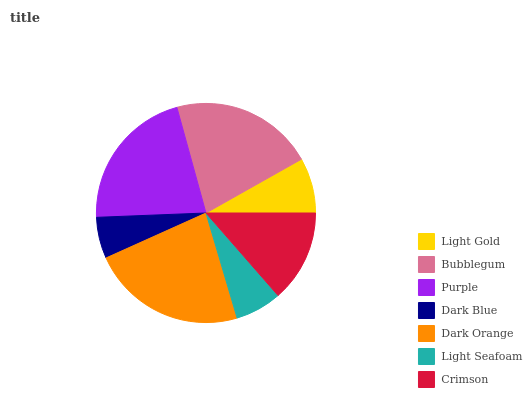Is Dark Blue the minimum?
Answer yes or no. Yes. Is Dark Orange the maximum?
Answer yes or no. Yes. Is Bubblegum the minimum?
Answer yes or no. No. Is Bubblegum the maximum?
Answer yes or no. No. Is Bubblegum greater than Light Gold?
Answer yes or no. Yes. Is Light Gold less than Bubblegum?
Answer yes or no. Yes. Is Light Gold greater than Bubblegum?
Answer yes or no. No. Is Bubblegum less than Light Gold?
Answer yes or no. No. Is Crimson the high median?
Answer yes or no. Yes. Is Crimson the low median?
Answer yes or no. Yes. Is Purple the high median?
Answer yes or no. No. Is Dark Blue the low median?
Answer yes or no. No. 